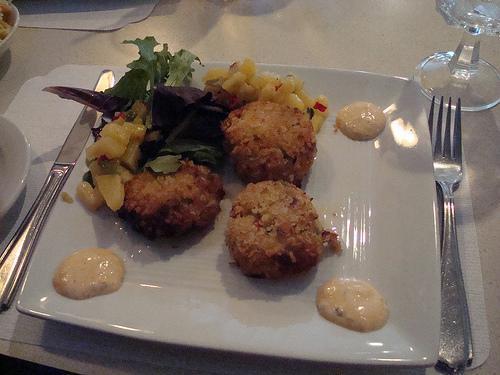How many dabs of sauce?
Give a very brief answer. 3. 